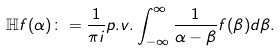<formula> <loc_0><loc_0><loc_500><loc_500>\mathbb { H } f ( \alpha ) \colon = \frac { 1 } { \pi i } p . v . \int _ { - \infty } ^ { \infty } \frac { 1 } { \alpha - \beta } f ( \beta ) d \beta .</formula> 